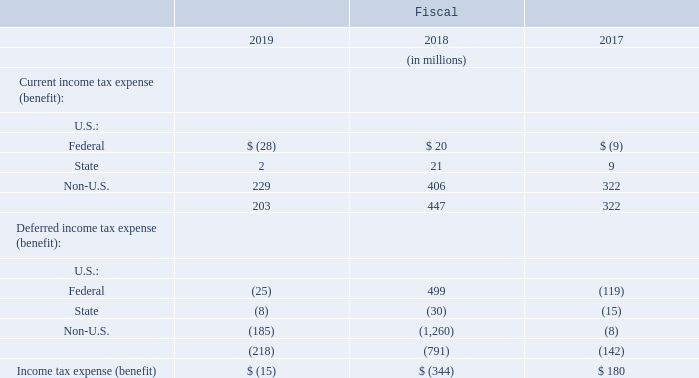Income Tax Expense (Benefit)
Significant components of the income tax expense (benefit) were as follows:
In which years was the Income Tax Expense (Benefit) calculated for? 2019, 2018, 2017. What are the components under U.S. in the table? Federal, state. What are the types of Income Tax Expense (Benefit) in the table? Current, deferred. Which year was the current income tax expense (benefit) for Non-U.S. the largest? 406>322>229
Answer: 2018. What was the change in Current income tax expense (benefit) in 2019 from 2018?
Answer scale should be: million. 203-447
Answer: -244. What was the percentage change in Current income tax expense (benefit) in 2019 from 2018?
Answer scale should be: percent. (203-447)/447
Answer: -54.59. 